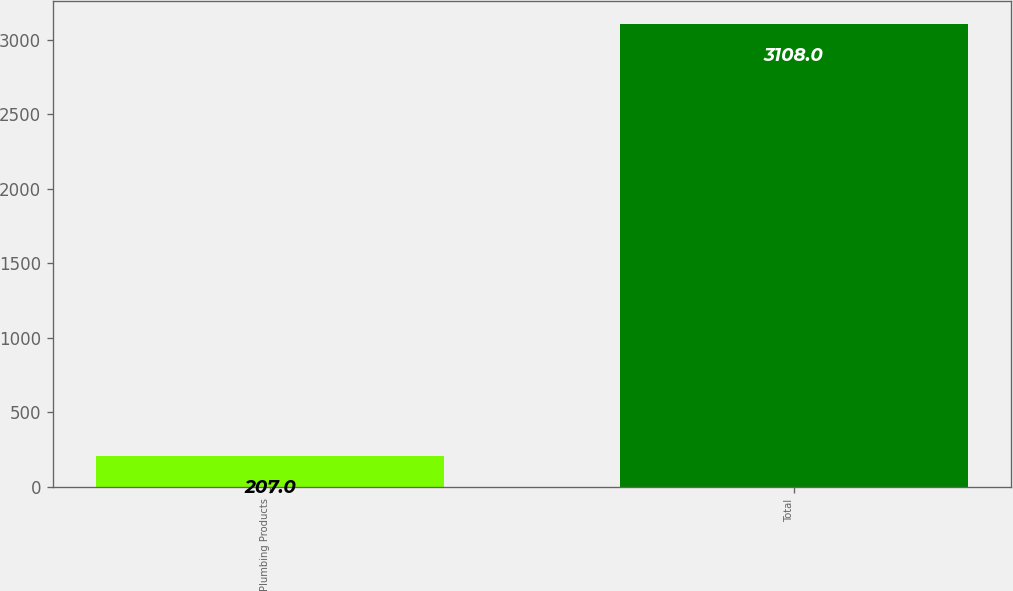Convert chart to OTSL. <chart><loc_0><loc_0><loc_500><loc_500><bar_chart><fcel>Plumbing Products<fcel>Total<nl><fcel>207<fcel>3108<nl></chart> 